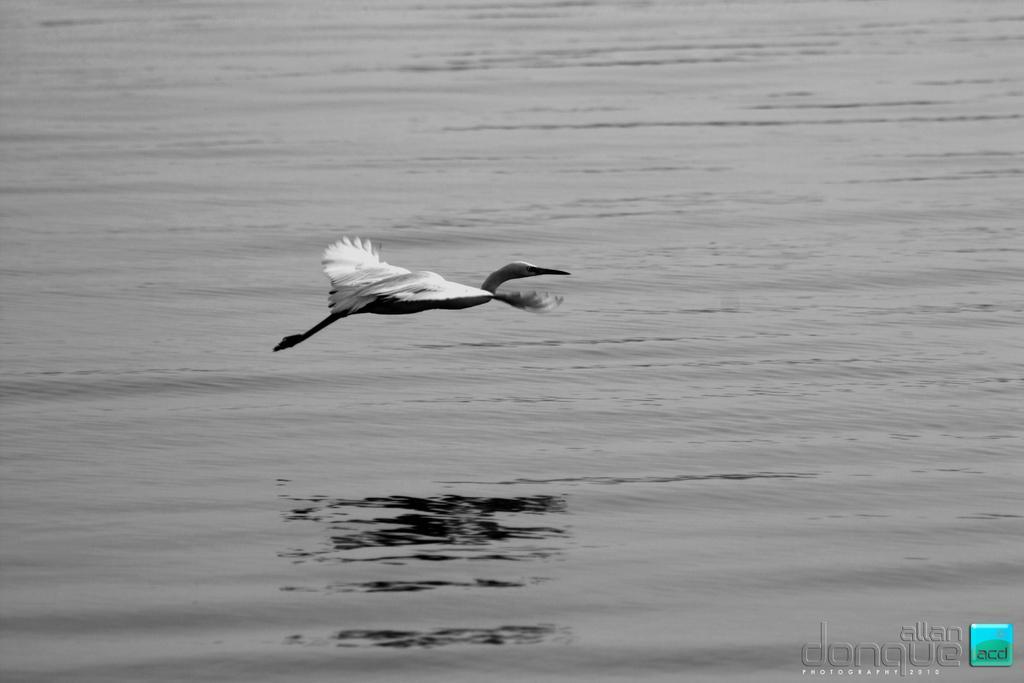In one or two sentences, can you explain what this image depicts? In this image there is water and a bird. Bird flying in the air. At the bottom right side of the image there is a watermark. 